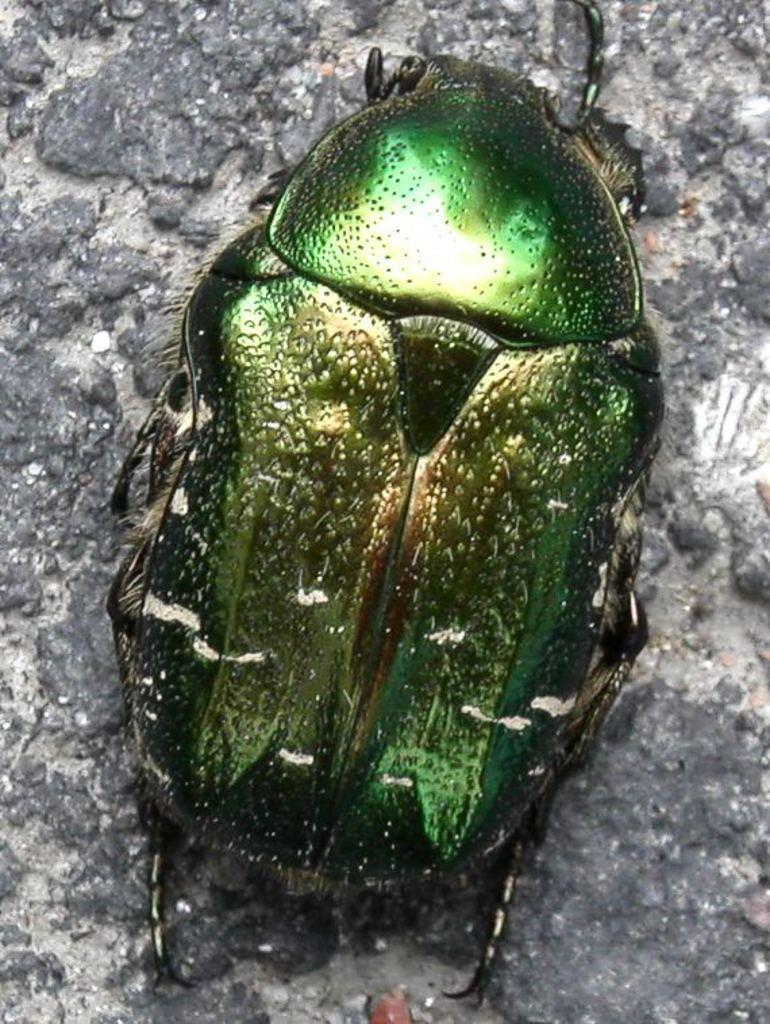What type of creature is present in the image? There is an insect in the image. What color is the insect? The insect is green in color. What is located at the bottom of the image? There is a rock at the bottom of the image. What is the appearance of the insect in the image? The insect appears to be shining. What type of question can be seen on the map in the image? There is no map or question present in the image; it features an insect and a rock. What shape is the insect in the image? The insect's shape cannot be determined from the image alone, as it is a photograph of a real insect and not a drawing or illustration. 